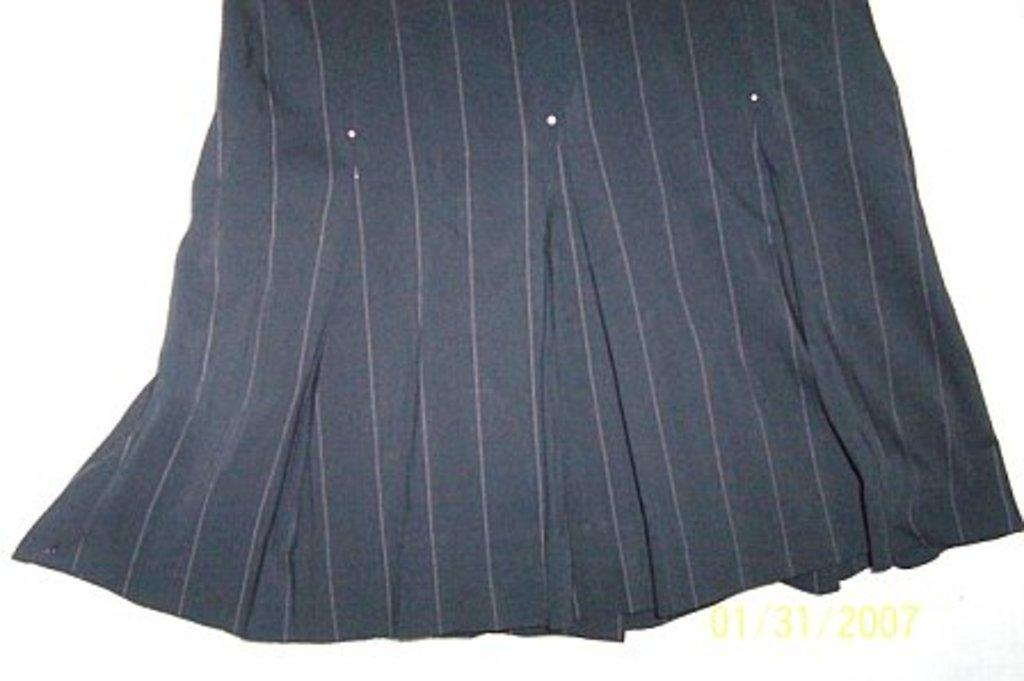What color is the cloth in the image? The cloth in the image is black. Are there any patterns or designs on the black cloth? Yes, there are pink lines on the black cloth. Is there any text or writing in the image? Yes, there is something written in the right corner of the image. How does the driver adjust the brake in the image? There is no driver or brake present in the image; it features a black cloth with pink lines and writing in the right corner. 